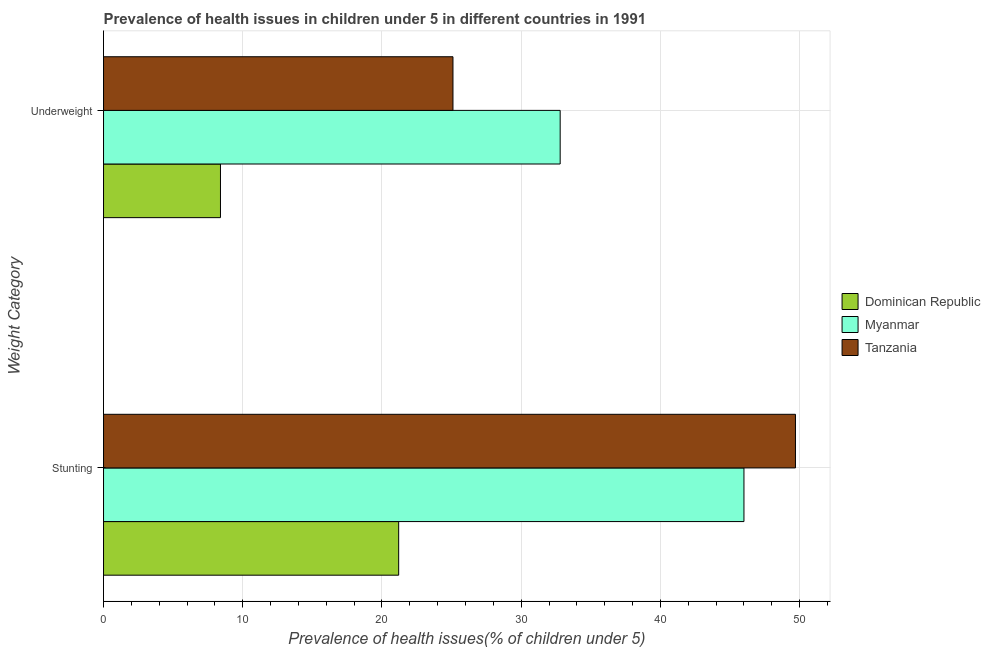How many different coloured bars are there?
Your answer should be very brief. 3. How many groups of bars are there?
Provide a short and direct response. 2. Are the number of bars on each tick of the Y-axis equal?
Keep it short and to the point. Yes. What is the label of the 1st group of bars from the top?
Your response must be concise. Underweight. What is the percentage of stunted children in Myanmar?
Provide a short and direct response. 46. Across all countries, what is the maximum percentage of underweight children?
Make the answer very short. 32.8. Across all countries, what is the minimum percentage of stunted children?
Keep it short and to the point. 21.2. In which country was the percentage of underweight children maximum?
Ensure brevity in your answer.  Myanmar. In which country was the percentage of stunted children minimum?
Keep it short and to the point. Dominican Republic. What is the total percentage of underweight children in the graph?
Provide a short and direct response. 66.3. What is the difference between the percentage of underweight children in Dominican Republic and that in Tanzania?
Make the answer very short. -16.7. What is the difference between the percentage of underweight children in Myanmar and the percentage of stunted children in Tanzania?
Offer a very short reply. -16.9. What is the average percentage of stunted children per country?
Keep it short and to the point. 38.97. What is the difference between the percentage of stunted children and percentage of underweight children in Dominican Republic?
Offer a terse response. 12.8. What is the ratio of the percentage of underweight children in Dominican Republic to that in Tanzania?
Ensure brevity in your answer.  0.33. Is the percentage of underweight children in Myanmar less than that in Tanzania?
Your response must be concise. No. In how many countries, is the percentage of underweight children greater than the average percentage of underweight children taken over all countries?
Provide a short and direct response. 2. What does the 1st bar from the top in Underweight represents?
Offer a very short reply. Tanzania. What does the 1st bar from the bottom in Stunting represents?
Your response must be concise. Dominican Republic. How many countries are there in the graph?
Provide a succinct answer. 3. What is the difference between two consecutive major ticks on the X-axis?
Your answer should be very brief. 10. Are the values on the major ticks of X-axis written in scientific E-notation?
Offer a very short reply. No. Does the graph contain any zero values?
Your answer should be compact. No. How many legend labels are there?
Provide a short and direct response. 3. What is the title of the graph?
Ensure brevity in your answer.  Prevalence of health issues in children under 5 in different countries in 1991. Does "Dominican Republic" appear as one of the legend labels in the graph?
Ensure brevity in your answer.  Yes. What is the label or title of the X-axis?
Keep it short and to the point. Prevalence of health issues(% of children under 5). What is the label or title of the Y-axis?
Your answer should be very brief. Weight Category. What is the Prevalence of health issues(% of children under 5) in Dominican Republic in Stunting?
Provide a succinct answer. 21.2. What is the Prevalence of health issues(% of children under 5) in Myanmar in Stunting?
Provide a short and direct response. 46. What is the Prevalence of health issues(% of children under 5) in Tanzania in Stunting?
Offer a terse response. 49.7. What is the Prevalence of health issues(% of children under 5) of Dominican Republic in Underweight?
Keep it short and to the point. 8.4. What is the Prevalence of health issues(% of children under 5) in Myanmar in Underweight?
Give a very brief answer. 32.8. What is the Prevalence of health issues(% of children under 5) in Tanzania in Underweight?
Provide a succinct answer. 25.1. Across all Weight Category, what is the maximum Prevalence of health issues(% of children under 5) in Dominican Republic?
Offer a very short reply. 21.2. Across all Weight Category, what is the maximum Prevalence of health issues(% of children under 5) of Myanmar?
Keep it short and to the point. 46. Across all Weight Category, what is the maximum Prevalence of health issues(% of children under 5) in Tanzania?
Offer a very short reply. 49.7. Across all Weight Category, what is the minimum Prevalence of health issues(% of children under 5) of Dominican Republic?
Offer a very short reply. 8.4. Across all Weight Category, what is the minimum Prevalence of health issues(% of children under 5) of Myanmar?
Keep it short and to the point. 32.8. Across all Weight Category, what is the minimum Prevalence of health issues(% of children under 5) in Tanzania?
Ensure brevity in your answer.  25.1. What is the total Prevalence of health issues(% of children under 5) of Dominican Republic in the graph?
Your answer should be compact. 29.6. What is the total Prevalence of health issues(% of children under 5) in Myanmar in the graph?
Offer a very short reply. 78.8. What is the total Prevalence of health issues(% of children under 5) of Tanzania in the graph?
Keep it short and to the point. 74.8. What is the difference between the Prevalence of health issues(% of children under 5) in Dominican Republic in Stunting and that in Underweight?
Your answer should be compact. 12.8. What is the difference between the Prevalence of health issues(% of children under 5) of Myanmar in Stunting and that in Underweight?
Your response must be concise. 13.2. What is the difference between the Prevalence of health issues(% of children under 5) of Tanzania in Stunting and that in Underweight?
Your response must be concise. 24.6. What is the difference between the Prevalence of health issues(% of children under 5) in Dominican Republic in Stunting and the Prevalence of health issues(% of children under 5) in Myanmar in Underweight?
Offer a terse response. -11.6. What is the difference between the Prevalence of health issues(% of children under 5) in Dominican Republic in Stunting and the Prevalence of health issues(% of children under 5) in Tanzania in Underweight?
Ensure brevity in your answer.  -3.9. What is the difference between the Prevalence of health issues(% of children under 5) in Myanmar in Stunting and the Prevalence of health issues(% of children under 5) in Tanzania in Underweight?
Your response must be concise. 20.9. What is the average Prevalence of health issues(% of children under 5) of Dominican Republic per Weight Category?
Offer a terse response. 14.8. What is the average Prevalence of health issues(% of children under 5) of Myanmar per Weight Category?
Offer a very short reply. 39.4. What is the average Prevalence of health issues(% of children under 5) in Tanzania per Weight Category?
Provide a short and direct response. 37.4. What is the difference between the Prevalence of health issues(% of children under 5) of Dominican Republic and Prevalence of health issues(% of children under 5) of Myanmar in Stunting?
Provide a short and direct response. -24.8. What is the difference between the Prevalence of health issues(% of children under 5) of Dominican Republic and Prevalence of health issues(% of children under 5) of Tanzania in Stunting?
Ensure brevity in your answer.  -28.5. What is the difference between the Prevalence of health issues(% of children under 5) in Dominican Republic and Prevalence of health issues(% of children under 5) in Myanmar in Underweight?
Provide a short and direct response. -24.4. What is the difference between the Prevalence of health issues(% of children under 5) of Dominican Republic and Prevalence of health issues(% of children under 5) of Tanzania in Underweight?
Offer a very short reply. -16.7. What is the ratio of the Prevalence of health issues(% of children under 5) of Dominican Republic in Stunting to that in Underweight?
Keep it short and to the point. 2.52. What is the ratio of the Prevalence of health issues(% of children under 5) in Myanmar in Stunting to that in Underweight?
Your answer should be compact. 1.4. What is the ratio of the Prevalence of health issues(% of children under 5) of Tanzania in Stunting to that in Underweight?
Give a very brief answer. 1.98. What is the difference between the highest and the second highest Prevalence of health issues(% of children under 5) of Tanzania?
Provide a succinct answer. 24.6. What is the difference between the highest and the lowest Prevalence of health issues(% of children under 5) in Tanzania?
Provide a short and direct response. 24.6. 